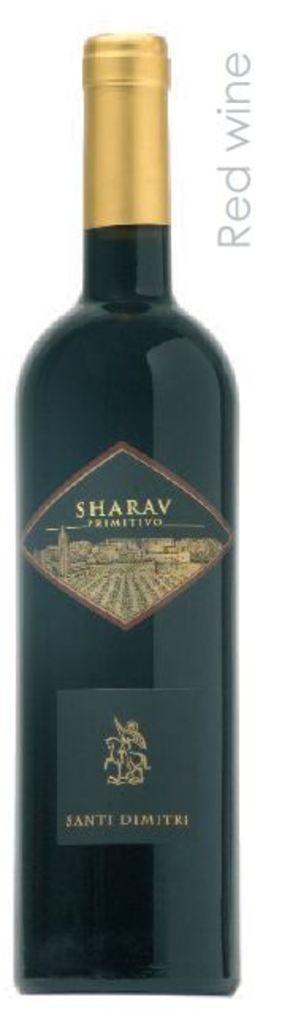<image>
Create a compact narrative representing the image presented. A long shot of a bottle of Santi Dimitri Red Wine 